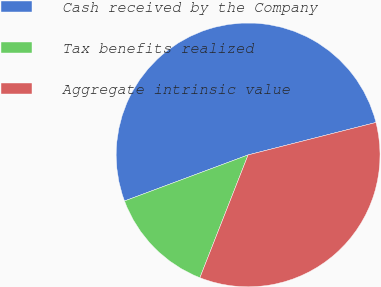Convert chart. <chart><loc_0><loc_0><loc_500><loc_500><pie_chart><fcel>Cash received by the Company<fcel>Tax benefits realized<fcel>Aggregate intrinsic value<nl><fcel>51.72%<fcel>13.37%<fcel>34.91%<nl></chart> 